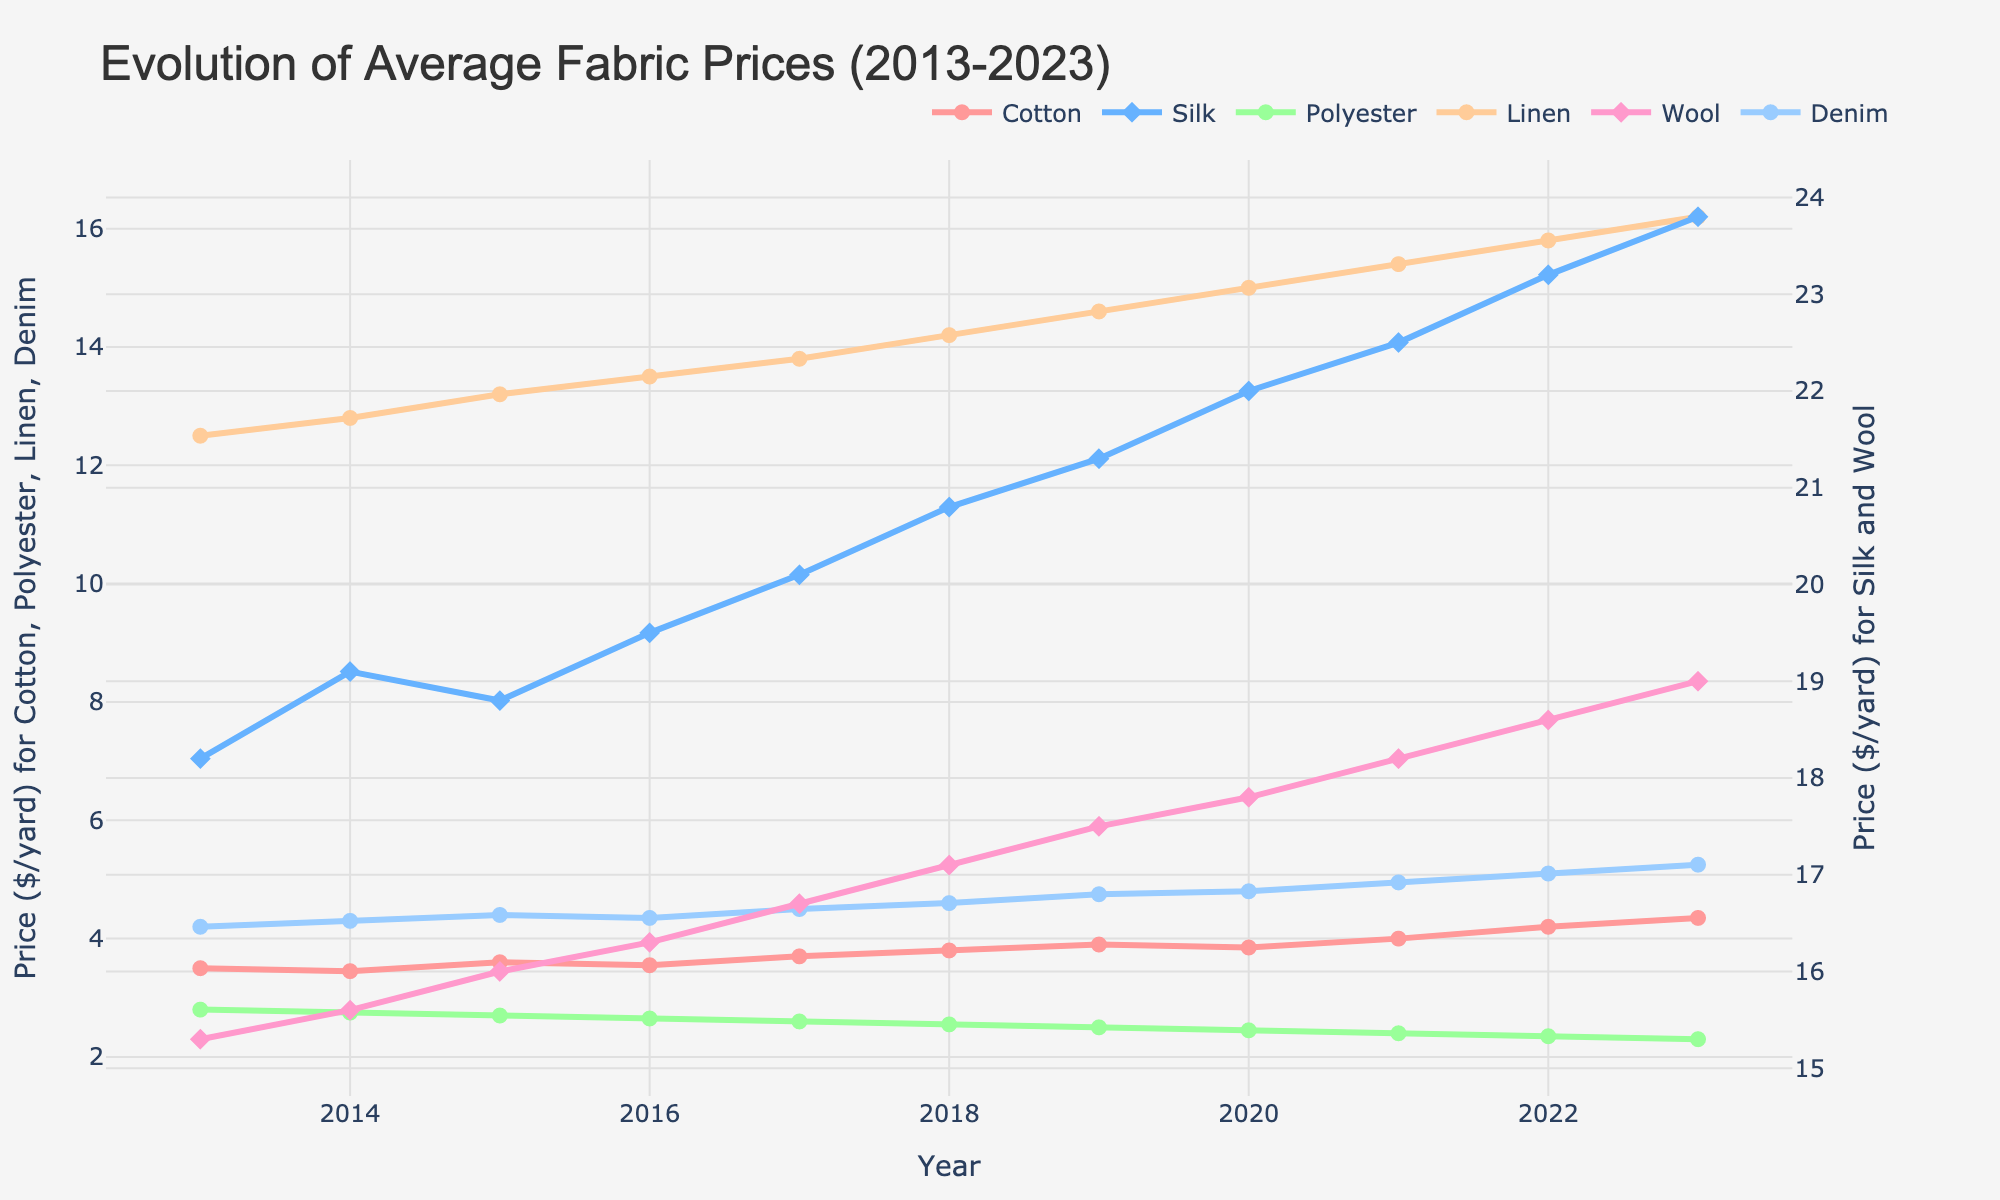What material had the highest average price in 2023? To answer this, observe the values on the y-axis for the year 2023 and identify the material with the highest price point. Silk's price is visibly the highest compared to other materials.
Answer: Silk Which material experienced the greatest increase in price from 2013 to 2023? To determine this, find the difference in prices from 2013 to 2023 for each material: 
Cotton: 4.35 - 3.50 = 0.85.
Silk: 23.80 - 18.20 = 5.60.
Polyester: 2.30 - 2.80 = -0.50.
Linen: 16.20 - 12.50 = 3.70.
Wool: 19.00 - 15.30 = 3.70.
Denim: 5.25 - 4.20 = 1.05.
Silk shows the greatest increase.
Answer: Silk How did the price of polyester trend over the years? Examine the polyester line from 2013 to 2023, noting its slope and direction. The price of polyester steadily decreases each year.
Answer: Decreasing What were the price differences between cotton and wool in 2020? Look at the price of cotton and wool in 2020 and subtract the values: Wool: 17.80, Cotton: 3.85. 17.80 - 3.85 = 13.95.
Answer: 13.95 Which years did all materials see a price gain compared to the previous year? Verify yearly increases for all materials by comparing each year's prices with the previous year's. Allowances for any year with uniform positive increments include 2018.
Answer: 2018 What was the average price of linen over the whole period? Sum linen prices from 2013-2023 and divide by the number of years (11): Average = (12.50 + 12.80 + 13.20 + 13.50 + 13.80 + 14.20 + 14.60 + 15.00 + 15.40 + 15.80 + 16.20) / 11 = 14.12
Answer: 14.12 Which materials had the smallest price difference between their highest and lowest points over the period? To find this, calculate the difference between the maximum and minimum prices for each material. Polyester: 2.80 - 2.30 = 0.50, showing the smallest range among all materials.
Answer: Polyester Is there any year when the price of denim increased while the price of silk decreased? Look for any year-to-year comparison where denim rises and silk falls. All yearly steps show concurrent increases, ruling out such a scenario.
Answer: No What color represents the silk price line in the chart? Identify the color assigned to the silk line from the visual attributes. Silk is denoted with a pinkish hue.
Answer: Pink Which material had a nearly constant price throughout the decade? Seek a line with minimal fluctuation over the years, which implies stability. Polyester line, relatively flat, depicts such pricing constancy.
Answer: Polyester 